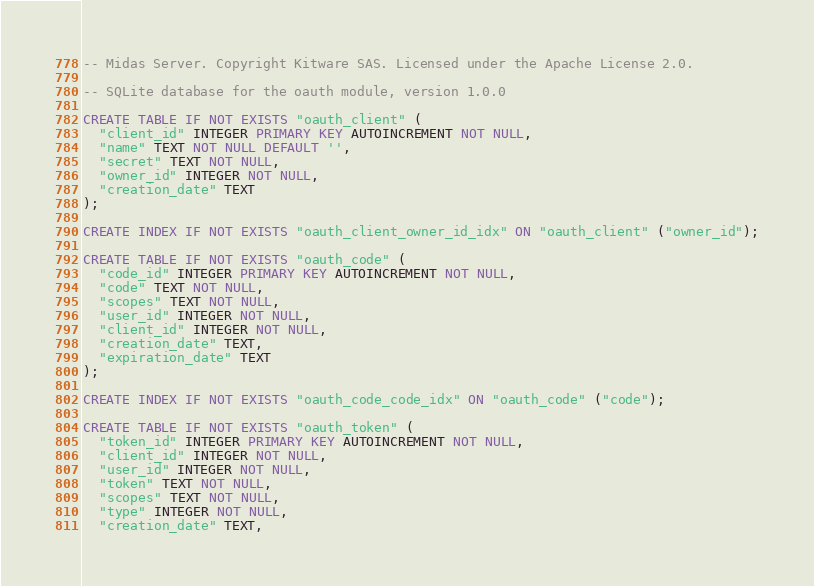<code> <loc_0><loc_0><loc_500><loc_500><_SQL_>-- Midas Server. Copyright Kitware SAS. Licensed under the Apache License 2.0.

-- SQLite database for the oauth module, version 1.0.0

CREATE TABLE IF NOT EXISTS "oauth_client" (
  "client_id" INTEGER PRIMARY KEY AUTOINCREMENT NOT NULL,
  "name" TEXT NOT NULL DEFAULT '',
  "secret" TEXT NOT NULL,
  "owner_id" INTEGER NOT NULL,
  "creation_date" TEXT
);

CREATE INDEX IF NOT EXISTS "oauth_client_owner_id_idx" ON "oauth_client" ("owner_id");

CREATE TABLE IF NOT EXISTS "oauth_code" (
  "code_id" INTEGER PRIMARY KEY AUTOINCREMENT NOT NULL,
  "code" TEXT NOT NULL,
  "scopes" TEXT NOT NULL,
  "user_id" INTEGER NOT NULL,
  "client_id" INTEGER NOT NULL,
  "creation_date" TEXT,
  "expiration_date" TEXT
);

CREATE INDEX IF NOT EXISTS "oauth_code_code_idx" ON "oauth_code" ("code");

CREATE TABLE IF NOT EXISTS "oauth_token" (
  "token_id" INTEGER PRIMARY KEY AUTOINCREMENT NOT NULL,
  "client_id" INTEGER NOT NULL,
  "user_id" INTEGER NOT NULL,
  "token" TEXT NOT NULL,
  "scopes" TEXT NOT NULL,
  "type" INTEGER NOT NULL,
  "creation_date" TEXT,</code> 